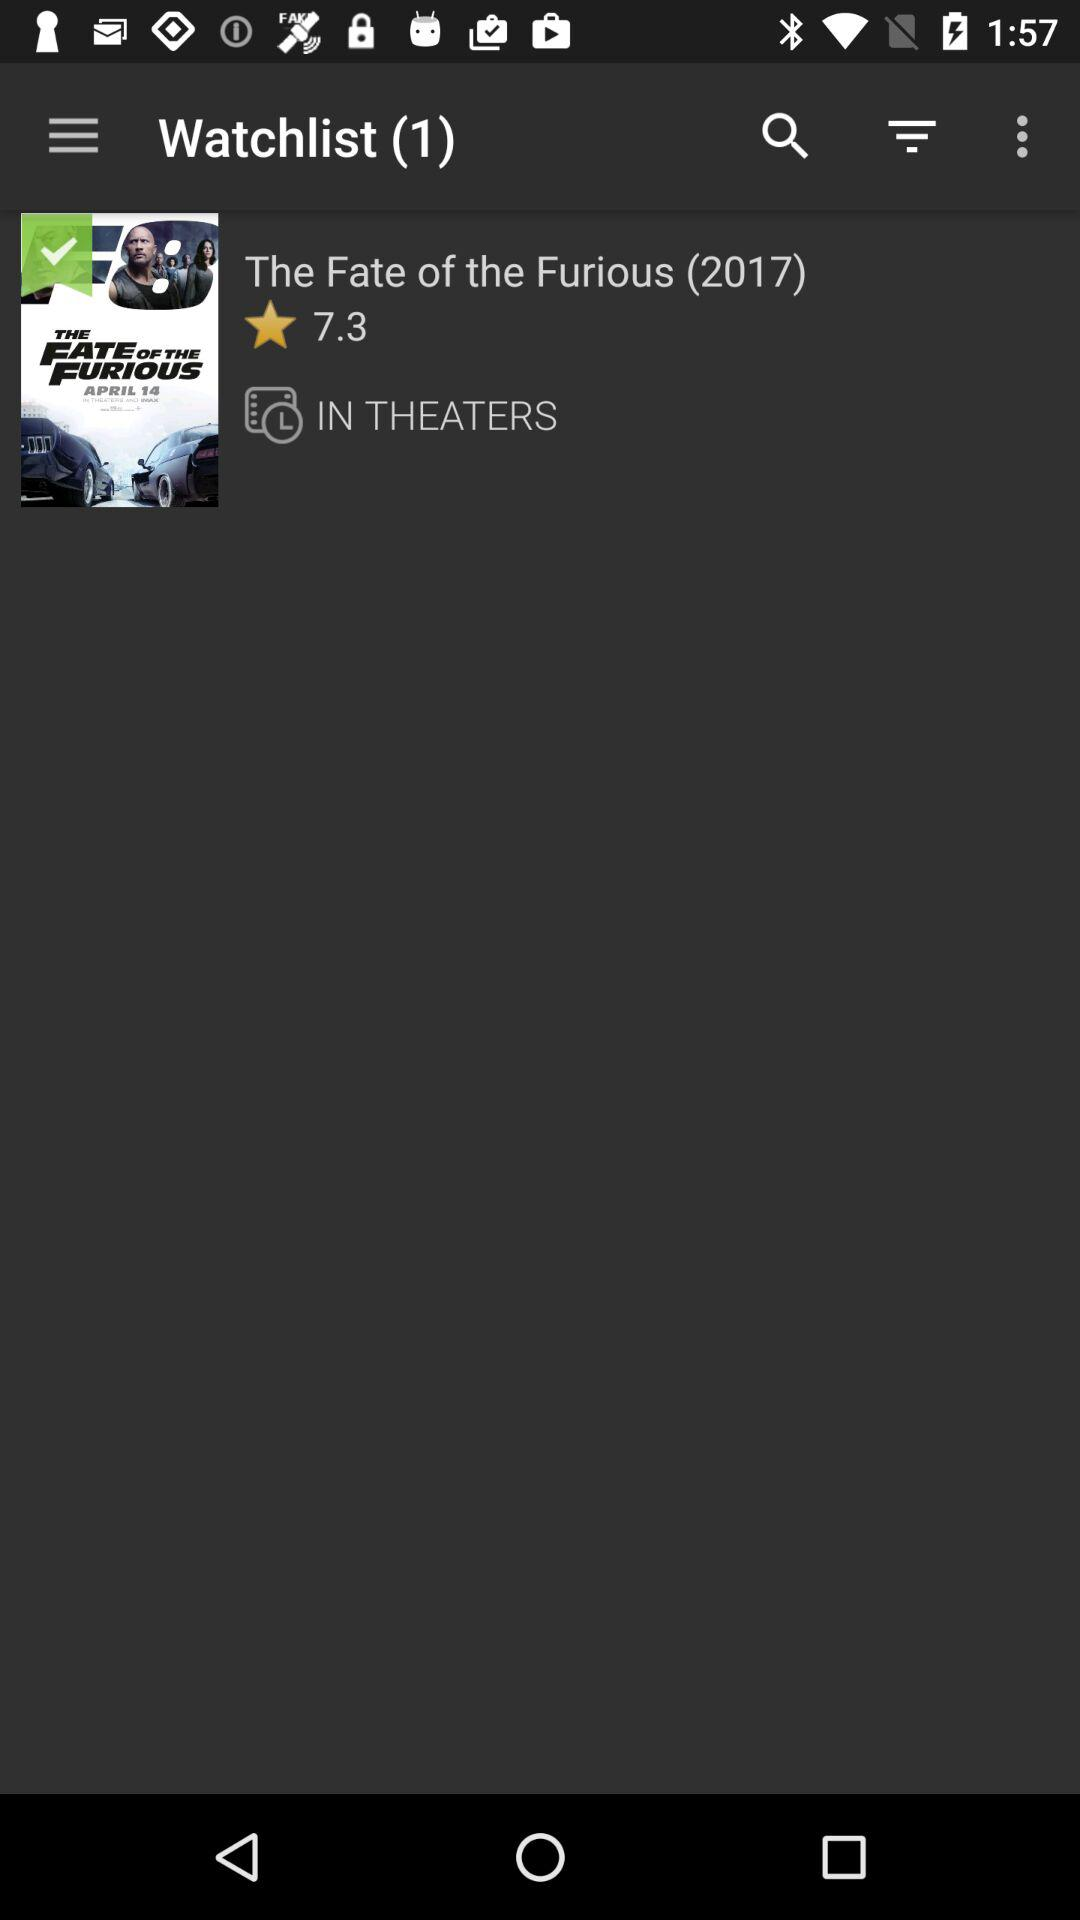How many movies are there on my watchlist? There is 1 movie on your watchlist. 